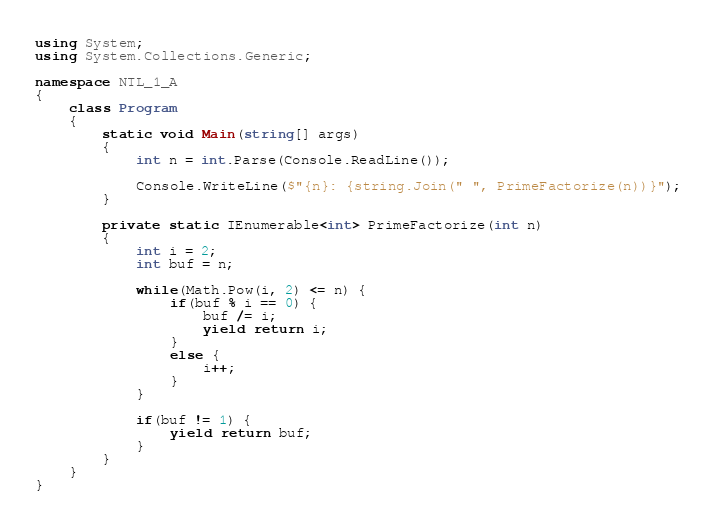<code> <loc_0><loc_0><loc_500><loc_500><_C#_>using System;
using System.Collections.Generic;

namespace NTL_1_A
{
	class Program
	{
		static void Main(string[] args)
		{
			int n = int.Parse(Console.ReadLine());

			Console.WriteLine($"{n}: {string.Join(" ", PrimeFactorize(n))}");
		}

		private static IEnumerable<int> PrimeFactorize(int n)
		{
			int i = 2;
			int buf = n;

			while(Math.Pow(i, 2) <= n) {
				if(buf % i == 0) {
					buf /= i;
					yield return i;
				}
				else {
					i++;
				}
			}

			if(buf != 1) {
				yield return buf;
			}
		}
	}
}

</code> 